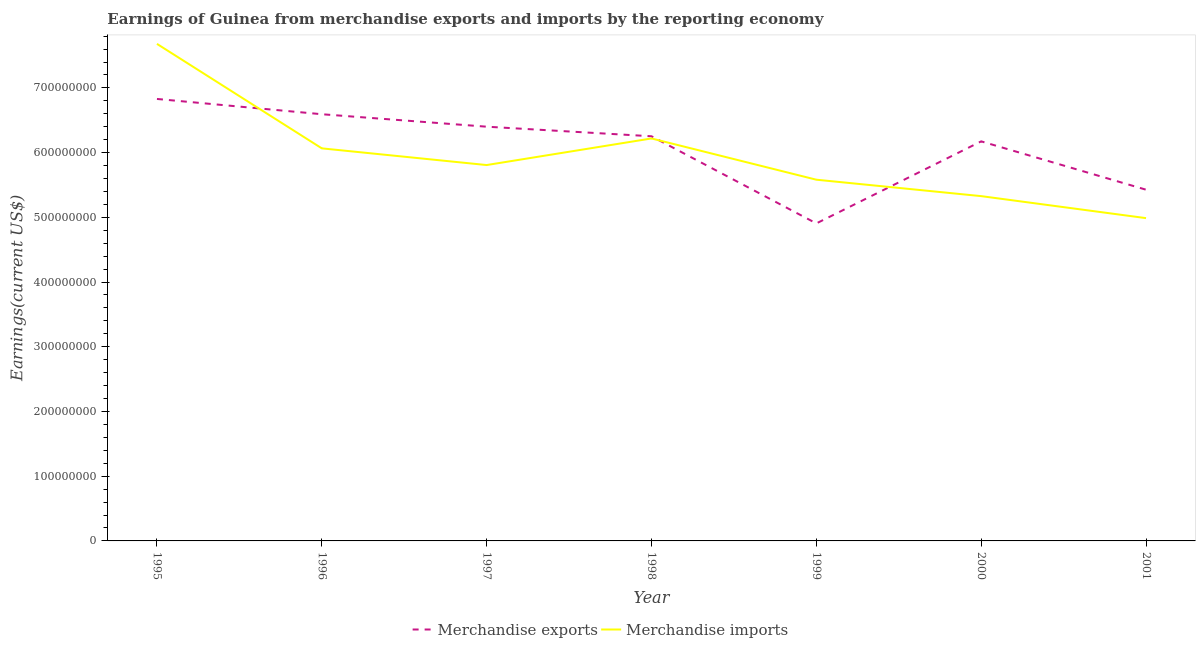How many different coloured lines are there?
Offer a very short reply. 2. Does the line corresponding to earnings from merchandise exports intersect with the line corresponding to earnings from merchandise imports?
Make the answer very short. Yes. Is the number of lines equal to the number of legend labels?
Ensure brevity in your answer.  Yes. What is the earnings from merchandise imports in 2001?
Your answer should be compact. 4.99e+08. Across all years, what is the maximum earnings from merchandise imports?
Offer a terse response. 7.68e+08. Across all years, what is the minimum earnings from merchandise imports?
Your answer should be very brief. 4.99e+08. In which year was the earnings from merchandise exports maximum?
Your answer should be very brief. 1995. What is the total earnings from merchandise imports in the graph?
Your answer should be compact. 4.17e+09. What is the difference between the earnings from merchandise imports in 1996 and that in 1999?
Give a very brief answer. 4.84e+07. What is the difference between the earnings from merchandise imports in 2000 and the earnings from merchandise exports in 2001?
Give a very brief answer. -9.94e+06. What is the average earnings from merchandise exports per year?
Your answer should be compact. 6.08e+08. In the year 1998, what is the difference between the earnings from merchandise exports and earnings from merchandise imports?
Make the answer very short. 3.37e+06. What is the ratio of the earnings from merchandise imports in 1998 to that in 1999?
Your answer should be very brief. 1.11. Is the earnings from merchandise imports in 1996 less than that in 2001?
Your response must be concise. No. What is the difference between the highest and the second highest earnings from merchandise exports?
Ensure brevity in your answer.  2.36e+07. What is the difference between the highest and the lowest earnings from merchandise imports?
Offer a very short reply. 2.69e+08. In how many years, is the earnings from merchandise imports greater than the average earnings from merchandise imports taken over all years?
Give a very brief answer. 3. Is the earnings from merchandise exports strictly greater than the earnings from merchandise imports over the years?
Make the answer very short. No. Is the earnings from merchandise imports strictly less than the earnings from merchandise exports over the years?
Your answer should be very brief. No. How many years are there in the graph?
Offer a terse response. 7. How are the legend labels stacked?
Make the answer very short. Horizontal. What is the title of the graph?
Give a very brief answer. Earnings of Guinea from merchandise exports and imports by the reporting economy. What is the label or title of the Y-axis?
Your answer should be compact. Earnings(current US$). What is the Earnings(current US$) in Merchandise exports in 1995?
Keep it short and to the point. 6.83e+08. What is the Earnings(current US$) of Merchandise imports in 1995?
Provide a short and direct response. 7.68e+08. What is the Earnings(current US$) of Merchandise exports in 1996?
Provide a succinct answer. 6.59e+08. What is the Earnings(current US$) in Merchandise imports in 1996?
Ensure brevity in your answer.  6.07e+08. What is the Earnings(current US$) of Merchandise exports in 1997?
Your response must be concise. 6.40e+08. What is the Earnings(current US$) in Merchandise imports in 1997?
Offer a terse response. 5.81e+08. What is the Earnings(current US$) of Merchandise exports in 1998?
Your answer should be very brief. 6.25e+08. What is the Earnings(current US$) in Merchandise imports in 1998?
Offer a very short reply. 6.22e+08. What is the Earnings(current US$) of Merchandise exports in 1999?
Make the answer very short. 4.91e+08. What is the Earnings(current US$) of Merchandise imports in 1999?
Ensure brevity in your answer.  5.58e+08. What is the Earnings(current US$) of Merchandise exports in 2000?
Offer a terse response. 6.17e+08. What is the Earnings(current US$) of Merchandise imports in 2000?
Your response must be concise. 5.33e+08. What is the Earnings(current US$) of Merchandise exports in 2001?
Offer a very short reply. 5.43e+08. What is the Earnings(current US$) of Merchandise imports in 2001?
Offer a terse response. 4.99e+08. Across all years, what is the maximum Earnings(current US$) in Merchandise exports?
Make the answer very short. 6.83e+08. Across all years, what is the maximum Earnings(current US$) in Merchandise imports?
Provide a short and direct response. 7.68e+08. Across all years, what is the minimum Earnings(current US$) in Merchandise exports?
Your answer should be very brief. 4.91e+08. Across all years, what is the minimum Earnings(current US$) of Merchandise imports?
Make the answer very short. 4.99e+08. What is the total Earnings(current US$) of Merchandise exports in the graph?
Provide a succinct answer. 4.26e+09. What is the total Earnings(current US$) in Merchandise imports in the graph?
Ensure brevity in your answer.  4.17e+09. What is the difference between the Earnings(current US$) in Merchandise exports in 1995 and that in 1996?
Give a very brief answer. 2.36e+07. What is the difference between the Earnings(current US$) of Merchandise imports in 1995 and that in 1996?
Your response must be concise. 1.61e+08. What is the difference between the Earnings(current US$) in Merchandise exports in 1995 and that in 1997?
Make the answer very short. 4.29e+07. What is the difference between the Earnings(current US$) in Merchandise imports in 1995 and that in 1997?
Give a very brief answer. 1.87e+08. What is the difference between the Earnings(current US$) of Merchandise exports in 1995 and that in 1998?
Offer a very short reply. 5.77e+07. What is the difference between the Earnings(current US$) in Merchandise imports in 1995 and that in 1998?
Make the answer very short. 1.46e+08. What is the difference between the Earnings(current US$) in Merchandise exports in 1995 and that in 1999?
Make the answer very short. 1.92e+08. What is the difference between the Earnings(current US$) of Merchandise imports in 1995 and that in 1999?
Offer a terse response. 2.10e+08. What is the difference between the Earnings(current US$) of Merchandise exports in 1995 and that in 2000?
Offer a very short reply. 6.55e+07. What is the difference between the Earnings(current US$) in Merchandise imports in 1995 and that in 2000?
Keep it short and to the point. 2.35e+08. What is the difference between the Earnings(current US$) in Merchandise exports in 1995 and that in 2001?
Your answer should be very brief. 1.40e+08. What is the difference between the Earnings(current US$) of Merchandise imports in 1995 and that in 2001?
Offer a terse response. 2.69e+08. What is the difference between the Earnings(current US$) of Merchandise exports in 1996 and that in 1997?
Your answer should be compact. 1.93e+07. What is the difference between the Earnings(current US$) of Merchandise imports in 1996 and that in 1997?
Offer a terse response. 2.58e+07. What is the difference between the Earnings(current US$) in Merchandise exports in 1996 and that in 1998?
Your response must be concise. 3.41e+07. What is the difference between the Earnings(current US$) in Merchandise imports in 1996 and that in 1998?
Provide a succinct answer. -1.53e+07. What is the difference between the Earnings(current US$) of Merchandise exports in 1996 and that in 1999?
Your answer should be compact. 1.69e+08. What is the difference between the Earnings(current US$) of Merchandise imports in 1996 and that in 1999?
Your answer should be compact. 4.84e+07. What is the difference between the Earnings(current US$) in Merchandise exports in 1996 and that in 2000?
Keep it short and to the point. 4.19e+07. What is the difference between the Earnings(current US$) of Merchandise imports in 1996 and that in 2000?
Provide a short and direct response. 7.38e+07. What is the difference between the Earnings(current US$) in Merchandise exports in 1996 and that in 2001?
Offer a terse response. 1.17e+08. What is the difference between the Earnings(current US$) of Merchandise imports in 1996 and that in 2001?
Provide a succinct answer. 1.08e+08. What is the difference between the Earnings(current US$) of Merchandise exports in 1997 and that in 1998?
Keep it short and to the point. 1.48e+07. What is the difference between the Earnings(current US$) in Merchandise imports in 1997 and that in 1998?
Provide a short and direct response. -4.11e+07. What is the difference between the Earnings(current US$) in Merchandise exports in 1997 and that in 1999?
Your answer should be compact. 1.49e+08. What is the difference between the Earnings(current US$) in Merchandise imports in 1997 and that in 1999?
Provide a short and direct response. 2.26e+07. What is the difference between the Earnings(current US$) of Merchandise exports in 1997 and that in 2000?
Provide a succinct answer. 2.27e+07. What is the difference between the Earnings(current US$) of Merchandise imports in 1997 and that in 2000?
Give a very brief answer. 4.80e+07. What is the difference between the Earnings(current US$) in Merchandise exports in 1997 and that in 2001?
Offer a very short reply. 9.74e+07. What is the difference between the Earnings(current US$) of Merchandise imports in 1997 and that in 2001?
Offer a terse response. 8.20e+07. What is the difference between the Earnings(current US$) of Merchandise exports in 1998 and that in 1999?
Keep it short and to the point. 1.35e+08. What is the difference between the Earnings(current US$) of Merchandise imports in 1998 and that in 1999?
Give a very brief answer. 6.37e+07. What is the difference between the Earnings(current US$) in Merchandise exports in 1998 and that in 2000?
Make the answer very short. 7.86e+06. What is the difference between the Earnings(current US$) of Merchandise imports in 1998 and that in 2000?
Ensure brevity in your answer.  8.91e+07. What is the difference between the Earnings(current US$) of Merchandise exports in 1998 and that in 2001?
Offer a terse response. 8.26e+07. What is the difference between the Earnings(current US$) in Merchandise imports in 1998 and that in 2001?
Offer a terse response. 1.23e+08. What is the difference between the Earnings(current US$) of Merchandise exports in 1999 and that in 2000?
Provide a short and direct response. -1.27e+08. What is the difference between the Earnings(current US$) of Merchandise imports in 1999 and that in 2000?
Your answer should be very brief. 2.54e+07. What is the difference between the Earnings(current US$) in Merchandise exports in 1999 and that in 2001?
Ensure brevity in your answer.  -5.21e+07. What is the difference between the Earnings(current US$) in Merchandise imports in 1999 and that in 2001?
Your response must be concise. 5.94e+07. What is the difference between the Earnings(current US$) in Merchandise exports in 2000 and that in 2001?
Keep it short and to the point. 7.47e+07. What is the difference between the Earnings(current US$) in Merchandise imports in 2000 and that in 2001?
Offer a terse response. 3.40e+07. What is the difference between the Earnings(current US$) in Merchandise exports in 1995 and the Earnings(current US$) in Merchandise imports in 1996?
Provide a succinct answer. 7.63e+07. What is the difference between the Earnings(current US$) of Merchandise exports in 1995 and the Earnings(current US$) of Merchandise imports in 1997?
Ensure brevity in your answer.  1.02e+08. What is the difference between the Earnings(current US$) of Merchandise exports in 1995 and the Earnings(current US$) of Merchandise imports in 1998?
Give a very brief answer. 6.10e+07. What is the difference between the Earnings(current US$) in Merchandise exports in 1995 and the Earnings(current US$) in Merchandise imports in 1999?
Ensure brevity in your answer.  1.25e+08. What is the difference between the Earnings(current US$) of Merchandise exports in 1995 and the Earnings(current US$) of Merchandise imports in 2000?
Make the answer very short. 1.50e+08. What is the difference between the Earnings(current US$) of Merchandise exports in 1995 and the Earnings(current US$) of Merchandise imports in 2001?
Your answer should be compact. 1.84e+08. What is the difference between the Earnings(current US$) of Merchandise exports in 1996 and the Earnings(current US$) of Merchandise imports in 1997?
Ensure brevity in your answer.  7.85e+07. What is the difference between the Earnings(current US$) of Merchandise exports in 1996 and the Earnings(current US$) of Merchandise imports in 1998?
Provide a succinct answer. 3.74e+07. What is the difference between the Earnings(current US$) in Merchandise exports in 1996 and the Earnings(current US$) in Merchandise imports in 1999?
Provide a short and direct response. 1.01e+08. What is the difference between the Earnings(current US$) in Merchandise exports in 1996 and the Earnings(current US$) in Merchandise imports in 2000?
Keep it short and to the point. 1.27e+08. What is the difference between the Earnings(current US$) of Merchandise exports in 1996 and the Earnings(current US$) of Merchandise imports in 2001?
Provide a short and direct response. 1.61e+08. What is the difference between the Earnings(current US$) of Merchandise exports in 1997 and the Earnings(current US$) of Merchandise imports in 1998?
Provide a short and direct response. 1.82e+07. What is the difference between the Earnings(current US$) in Merchandise exports in 1997 and the Earnings(current US$) in Merchandise imports in 1999?
Your response must be concise. 8.19e+07. What is the difference between the Earnings(current US$) in Merchandise exports in 1997 and the Earnings(current US$) in Merchandise imports in 2000?
Offer a terse response. 1.07e+08. What is the difference between the Earnings(current US$) of Merchandise exports in 1997 and the Earnings(current US$) of Merchandise imports in 2001?
Offer a terse response. 1.41e+08. What is the difference between the Earnings(current US$) in Merchandise exports in 1998 and the Earnings(current US$) in Merchandise imports in 1999?
Provide a succinct answer. 6.71e+07. What is the difference between the Earnings(current US$) of Merchandise exports in 1998 and the Earnings(current US$) of Merchandise imports in 2000?
Your answer should be very brief. 9.25e+07. What is the difference between the Earnings(current US$) of Merchandise exports in 1998 and the Earnings(current US$) of Merchandise imports in 2001?
Provide a succinct answer. 1.26e+08. What is the difference between the Earnings(current US$) of Merchandise exports in 1999 and the Earnings(current US$) of Merchandise imports in 2000?
Make the answer very short. -4.21e+07. What is the difference between the Earnings(current US$) of Merchandise exports in 1999 and the Earnings(current US$) of Merchandise imports in 2001?
Provide a short and direct response. -8.16e+06. What is the difference between the Earnings(current US$) of Merchandise exports in 2000 and the Earnings(current US$) of Merchandise imports in 2001?
Your answer should be compact. 1.19e+08. What is the average Earnings(current US$) in Merchandise exports per year?
Keep it short and to the point. 6.08e+08. What is the average Earnings(current US$) of Merchandise imports per year?
Provide a succinct answer. 5.95e+08. In the year 1995, what is the difference between the Earnings(current US$) in Merchandise exports and Earnings(current US$) in Merchandise imports?
Keep it short and to the point. -8.51e+07. In the year 1996, what is the difference between the Earnings(current US$) in Merchandise exports and Earnings(current US$) in Merchandise imports?
Provide a short and direct response. 5.27e+07. In the year 1997, what is the difference between the Earnings(current US$) of Merchandise exports and Earnings(current US$) of Merchandise imports?
Keep it short and to the point. 5.93e+07. In the year 1998, what is the difference between the Earnings(current US$) in Merchandise exports and Earnings(current US$) in Merchandise imports?
Your answer should be very brief. 3.37e+06. In the year 1999, what is the difference between the Earnings(current US$) of Merchandise exports and Earnings(current US$) of Merchandise imports?
Provide a succinct answer. -6.75e+07. In the year 2000, what is the difference between the Earnings(current US$) in Merchandise exports and Earnings(current US$) in Merchandise imports?
Offer a terse response. 8.46e+07. In the year 2001, what is the difference between the Earnings(current US$) of Merchandise exports and Earnings(current US$) of Merchandise imports?
Make the answer very short. 4.39e+07. What is the ratio of the Earnings(current US$) in Merchandise exports in 1995 to that in 1996?
Your response must be concise. 1.04. What is the ratio of the Earnings(current US$) of Merchandise imports in 1995 to that in 1996?
Your answer should be very brief. 1.27. What is the ratio of the Earnings(current US$) in Merchandise exports in 1995 to that in 1997?
Give a very brief answer. 1.07. What is the ratio of the Earnings(current US$) of Merchandise imports in 1995 to that in 1997?
Offer a very short reply. 1.32. What is the ratio of the Earnings(current US$) of Merchandise exports in 1995 to that in 1998?
Make the answer very short. 1.09. What is the ratio of the Earnings(current US$) in Merchandise imports in 1995 to that in 1998?
Provide a short and direct response. 1.24. What is the ratio of the Earnings(current US$) in Merchandise exports in 1995 to that in 1999?
Your answer should be compact. 1.39. What is the ratio of the Earnings(current US$) of Merchandise imports in 1995 to that in 1999?
Give a very brief answer. 1.38. What is the ratio of the Earnings(current US$) in Merchandise exports in 1995 to that in 2000?
Ensure brevity in your answer.  1.11. What is the ratio of the Earnings(current US$) of Merchandise imports in 1995 to that in 2000?
Provide a succinct answer. 1.44. What is the ratio of the Earnings(current US$) in Merchandise exports in 1995 to that in 2001?
Ensure brevity in your answer.  1.26. What is the ratio of the Earnings(current US$) of Merchandise imports in 1995 to that in 2001?
Keep it short and to the point. 1.54. What is the ratio of the Earnings(current US$) in Merchandise exports in 1996 to that in 1997?
Your answer should be very brief. 1.03. What is the ratio of the Earnings(current US$) of Merchandise imports in 1996 to that in 1997?
Your answer should be very brief. 1.04. What is the ratio of the Earnings(current US$) in Merchandise exports in 1996 to that in 1998?
Give a very brief answer. 1.05. What is the ratio of the Earnings(current US$) of Merchandise imports in 1996 to that in 1998?
Give a very brief answer. 0.98. What is the ratio of the Earnings(current US$) of Merchandise exports in 1996 to that in 1999?
Offer a terse response. 1.34. What is the ratio of the Earnings(current US$) in Merchandise imports in 1996 to that in 1999?
Give a very brief answer. 1.09. What is the ratio of the Earnings(current US$) in Merchandise exports in 1996 to that in 2000?
Offer a very short reply. 1.07. What is the ratio of the Earnings(current US$) in Merchandise imports in 1996 to that in 2000?
Your response must be concise. 1.14. What is the ratio of the Earnings(current US$) in Merchandise exports in 1996 to that in 2001?
Provide a short and direct response. 1.21. What is the ratio of the Earnings(current US$) in Merchandise imports in 1996 to that in 2001?
Offer a terse response. 1.22. What is the ratio of the Earnings(current US$) in Merchandise exports in 1997 to that in 1998?
Offer a very short reply. 1.02. What is the ratio of the Earnings(current US$) of Merchandise imports in 1997 to that in 1998?
Your answer should be compact. 0.93. What is the ratio of the Earnings(current US$) of Merchandise exports in 1997 to that in 1999?
Provide a short and direct response. 1.3. What is the ratio of the Earnings(current US$) in Merchandise imports in 1997 to that in 1999?
Your response must be concise. 1.04. What is the ratio of the Earnings(current US$) of Merchandise exports in 1997 to that in 2000?
Your answer should be very brief. 1.04. What is the ratio of the Earnings(current US$) of Merchandise imports in 1997 to that in 2000?
Offer a terse response. 1.09. What is the ratio of the Earnings(current US$) of Merchandise exports in 1997 to that in 2001?
Offer a very short reply. 1.18. What is the ratio of the Earnings(current US$) of Merchandise imports in 1997 to that in 2001?
Your answer should be very brief. 1.16. What is the ratio of the Earnings(current US$) of Merchandise exports in 1998 to that in 1999?
Your answer should be very brief. 1.27. What is the ratio of the Earnings(current US$) of Merchandise imports in 1998 to that in 1999?
Give a very brief answer. 1.11. What is the ratio of the Earnings(current US$) in Merchandise exports in 1998 to that in 2000?
Provide a succinct answer. 1.01. What is the ratio of the Earnings(current US$) of Merchandise imports in 1998 to that in 2000?
Your response must be concise. 1.17. What is the ratio of the Earnings(current US$) in Merchandise exports in 1998 to that in 2001?
Ensure brevity in your answer.  1.15. What is the ratio of the Earnings(current US$) in Merchandise imports in 1998 to that in 2001?
Keep it short and to the point. 1.25. What is the ratio of the Earnings(current US$) of Merchandise exports in 1999 to that in 2000?
Provide a short and direct response. 0.79. What is the ratio of the Earnings(current US$) in Merchandise imports in 1999 to that in 2000?
Your answer should be compact. 1.05. What is the ratio of the Earnings(current US$) in Merchandise exports in 1999 to that in 2001?
Give a very brief answer. 0.9. What is the ratio of the Earnings(current US$) of Merchandise imports in 1999 to that in 2001?
Ensure brevity in your answer.  1.12. What is the ratio of the Earnings(current US$) in Merchandise exports in 2000 to that in 2001?
Your answer should be compact. 1.14. What is the ratio of the Earnings(current US$) in Merchandise imports in 2000 to that in 2001?
Provide a short and direct response. 1.07. What is the difference between the highest and the second highest Earnings(current US$) of Merchandise exports?
Your answer should be compact. 2.36e+07. What is the difference between the highest and the second highest Earnings(current US$) in Merchandise imports?
Make the answer very short. 1.46e+08. What is the difference between the highest and the lowest Earnings(current US$) in Merchandise exports?
Provide a short and direct response. 1.92e+08. What is the difference between the highest and the lowest Earnings(current US$) in Merchandise imports?
Offer a very short reply. 2.69e+08. 